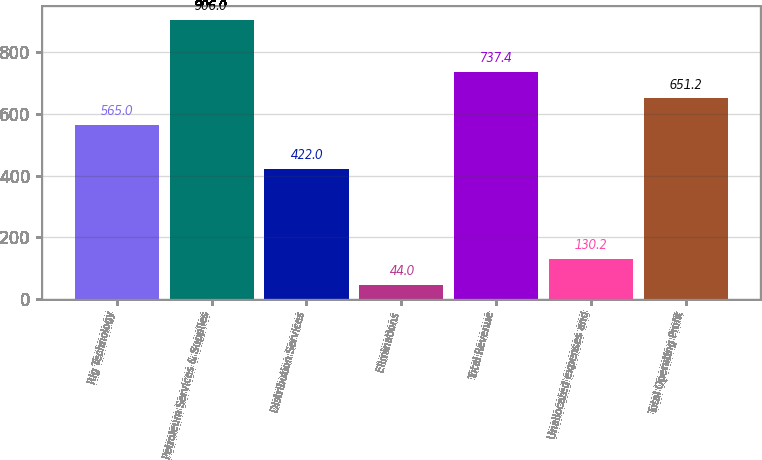Convert chart to OTSL. <chart><loc_0><loc_0><loc_500><loc_500><bar_chart><fcel>Rig Technology<fcel>Petroleum Services & Supplies<fcel>Distribution Services<fcel>Eliminations<fcel>Total Revenue<fcel>Unallocated expenses and<fcel>Total Operating Profit<nl><fcel>565<fcel>906<fcel>422<fcel>44<fcel>737.4<fcel>130.2<fcel>651.2<nl></chart> 